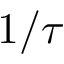Convert formula to latex. <formula><loc_0><loc_0><loc_500><loc_500>1 / \tau</formula> 